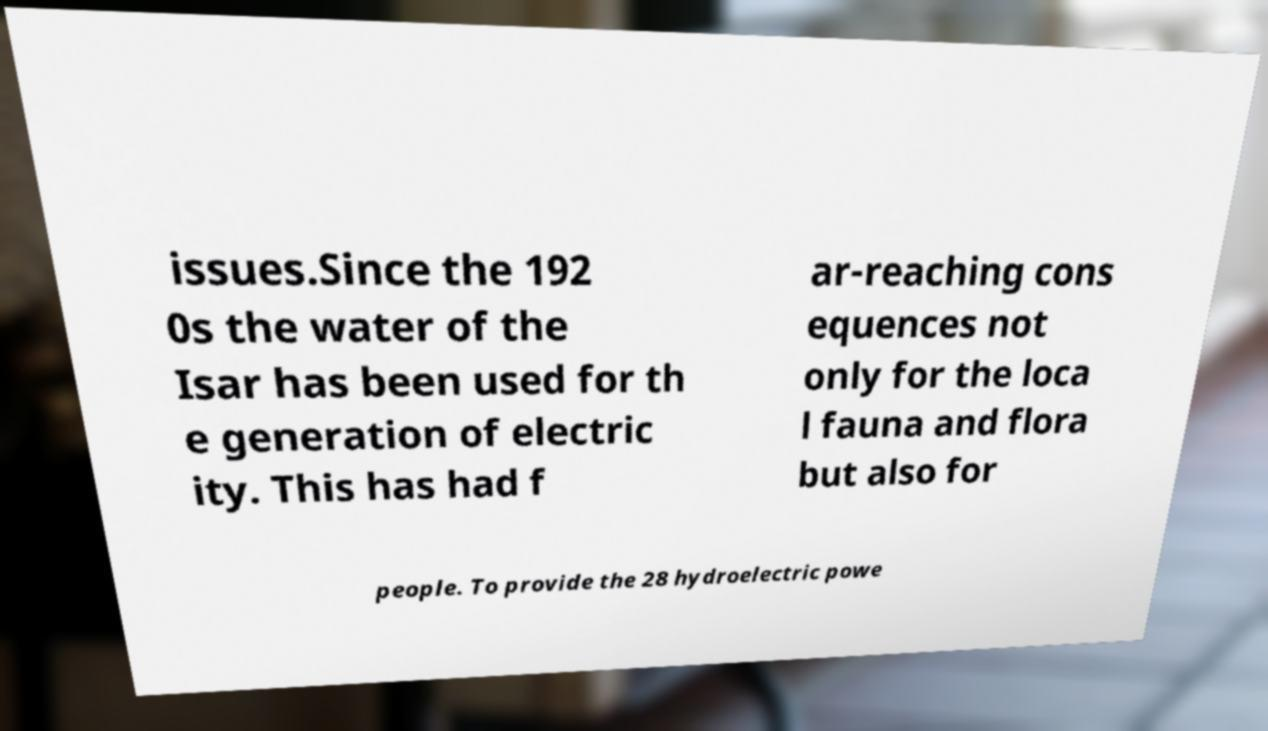Please read and relay the text visible in this image. What does it say? issues.Since the 192 0s the water of the Isar has been used for th e generation of electric ity. This has had f ar-reaching cons equences not only for the loca l fauna and flora but also for people. To provide the 28 hydroelectric powe 